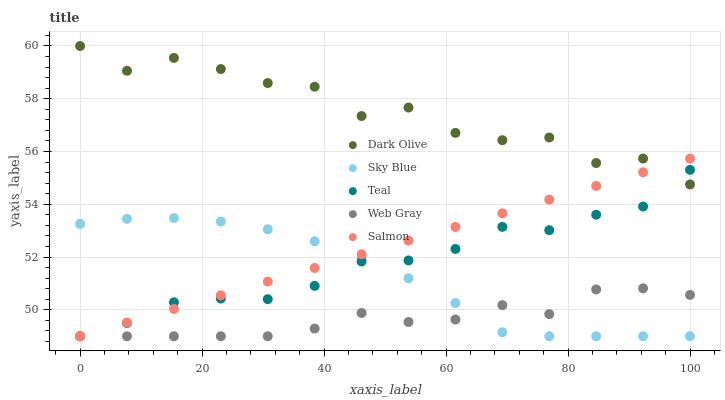Does Web Gray have the minimum area under the curve?
Answer yes or no. Yes. Does Dark Olive have the maximum area under the curve?
Answer yes or no. Yes. Does Dark Olive have the minimum area under the curve?
Answer yes or no. No. Does Web Gray have the maximum area under the curve?
Answer yes or no. No. Is Salmon the smoothest?
Answer yes or no. Yes. Is Dark Olive the roughest?
Answer yes or no. Yes. Is Web Gray the smoothest?
Answer yes or no. No. Is Web Gray the roughest?
Answer yes or no. No. Does Sky Blue have the lowest value?
Answer yes or no. Yes. Does Dark Olive have the lowest value?
Answer yes or no. No. Does Dark Olive have the highest value?
Answer yes or no. Yes. Does Web Gray have the highest value?
Answer yes or no. No. Is Sky Blue less than Dark Olive?
Answer yes or no. Yes. Is Dark Olive greater than Sky Blue?
Answer yes or no. Yes. Does Sky Blue intersect Web Gray?
Answer yes or no. Yes. Is Sky Blue less than Web Gray?
Answer yes or no. No. Is Sky Blue greater than Web Gray?
Answer yes or no. No. Does Sky Blue intersect Dark Olive?
Answer yes or no. No. 